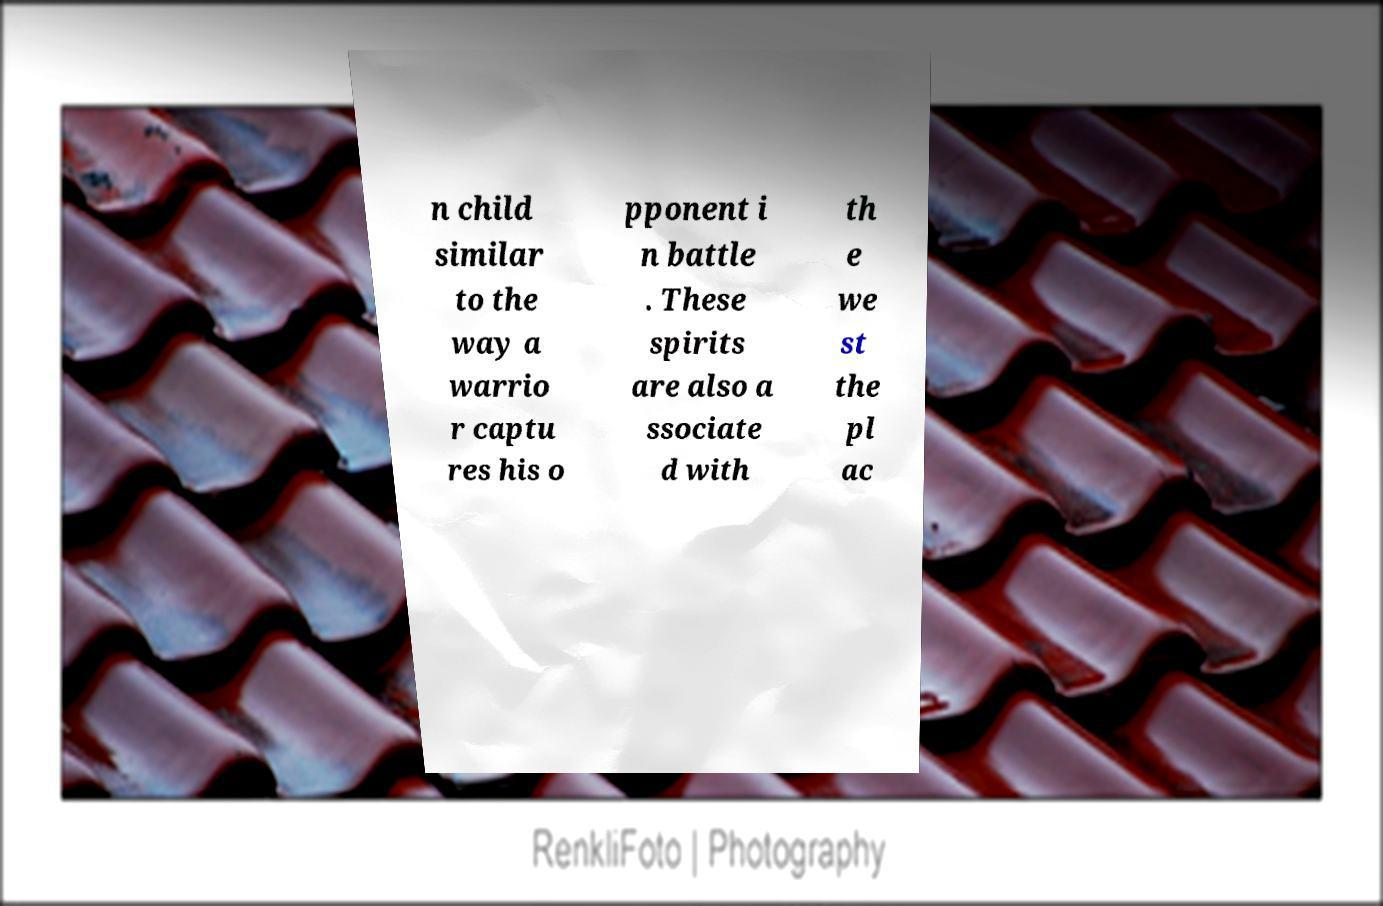For documentation purposes, I need the text within this image transcribed. Could you provide that? n child similar to the way a warrio r captu res his o pponent i n battle . These spirits are also a ssociate d with th e we st the pl ac 